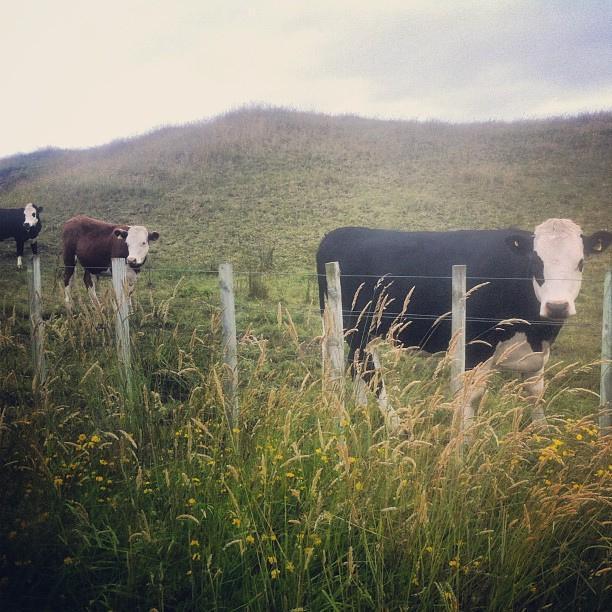How many cows are there?
Give a very brief answer. 3. 